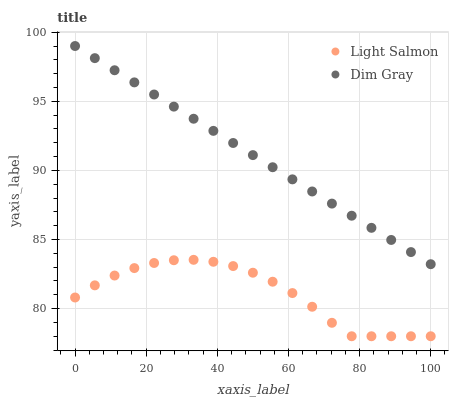Does Light Salmon have the minimum area under the curve?
Answer yes or no. Yes. Does Dim Gray have the maximum area under the curve?
Answer yes or no. Yes. Does Dim Gray have the minimum area under the curve?
Answer yes or no. No. Is Dim Gray the smoothest?
Answer yes or no. Yes. Is Light Salmon the roughest?
Answer yes or no. Yes. Is Dim Gray the roughest?
Answer yes or no. No. Does Light Salmon have the lowest value?
Answer yes or no. Yes. Does Dim Gray have the lowest value?
Answer yes or no. No. Does Dim Gray have the highest value?
Answer yes or no. Yes. Is Light Salmon less than Dim Gray?
Answer yes or no. Yes. Is Dim Gray greater than Light Salmon?
Answer yes or no. Yes. Does Light Salmon intersect Dim Gray?
Answer yes or no. No. 